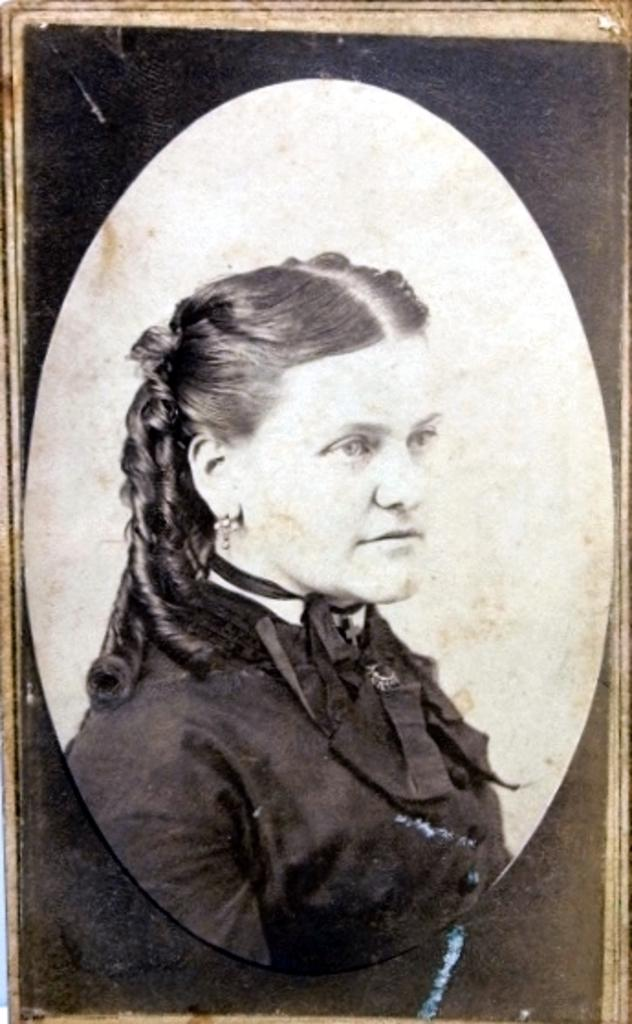What is the main subject of the image? There is a photograph of a woman in the image. What is the woman wearing in the image? The woman is wearing a black coat in the image. In which direction is the woman looking? The woman is looking to the right side in the image. What type of mountain can be seen in the background of the image? There is no mountain present in the image; it features a photograph of a woman wearing a black coat and looking to the right side. 